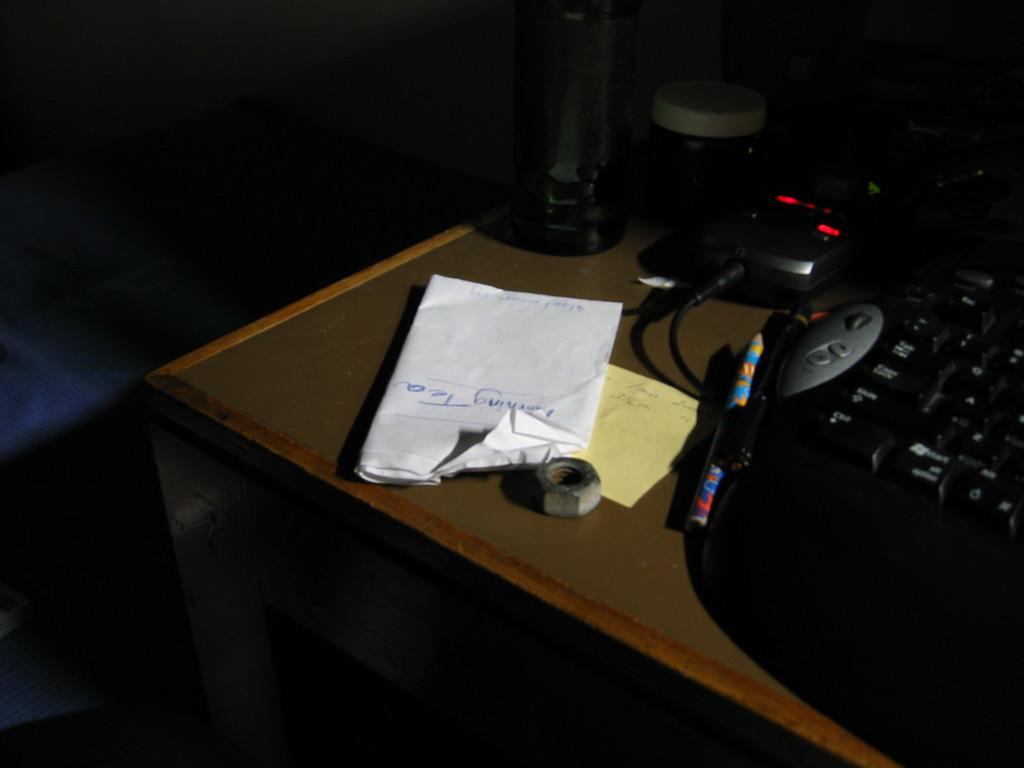What piece of furniture is in the room? There is a table in the room. What is placed on the table? A keyboard, pens, papers, a water bottle, a nut, and a box are present on the table. What might be used for typing or inputting data in the image? The keyboard on the table can be used for typing or inputting data. What can be used for writing in the image? The pens on the table can be used for writing. What type of learning event is taking place in the image? There is no indication of a learning event or any people in the image, so it cannot be determined from the image. 